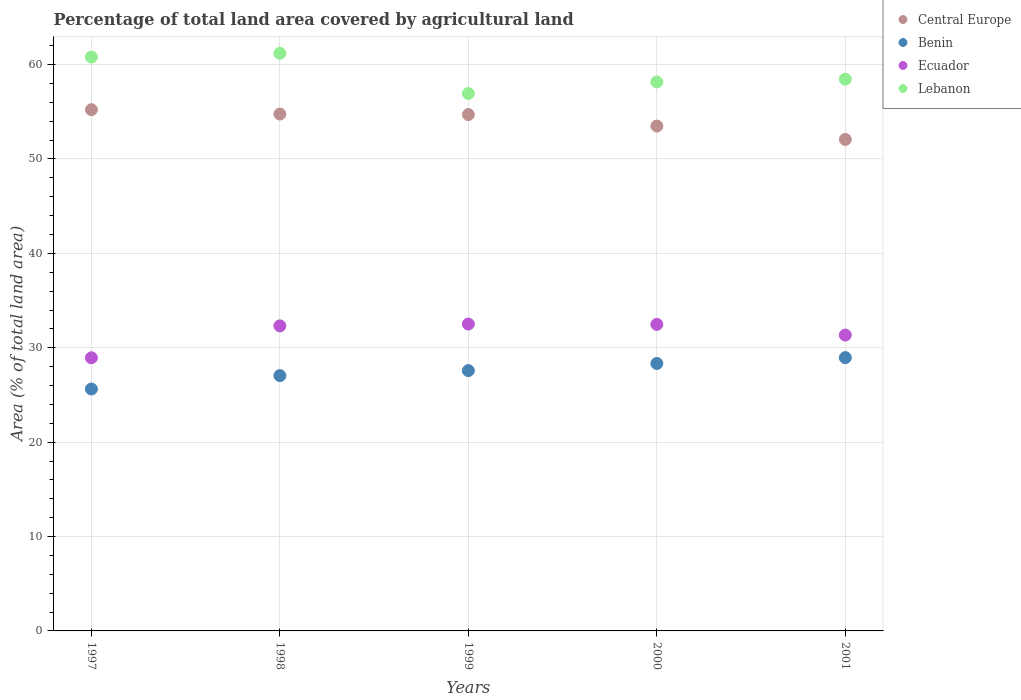Is the number of dotlines equal to the number of legend labels?
Keep it short and to the point. Yes. What is the percentage of agricultural land in Central Europe in 1998?
Keep it short and to the point. 54.76. Across all years, what is the maximum percentage of agricultural land in Lebanon?
Your answer should be compact. 61.19. Across all years, what is the minimum percentage of agricultural land in Benin?
Your answer should be compact. 25.63. In which year was the percentage of agricultural land in Lebanon maximum?
Your answer should be compact. 1998. In which year was the percentage of agricultural land in Lebanon minimum?
Your answer should be very brief. 1999. What is the total percentage of agricultural land in Lebanon in the graph?
Give a very brief answer. 295.55. What is the difference between the percentage of agricultural land in Central Europe in 1999 and that in 2001?
Provide a short and direct response. 2.63. What is the difference between the percentage of agricultural land in Benin in 1999 and the percentage of agricultural land in Ecuador in 2000?
Your answer should be very brief. -4.9. What is the average percentage of agricultural land in Lebanon per year?
Your response must be concise. 59.11. In the year 1997, what is the difference between the percentage of agricultural land in Central Europe and percentage of agricultural land in Lebanon?
Give a very brief answer. -5.57. What is the ratio of the percentage of agricultural land in Lebanon in 1999 to that in 2000?
Your response must be concise. 0.98. Is the percentage of agricultural land in Central Europe in 1999 less than that in 2000?
Provide a succinct answer. No. What is the difference between the highest and the second highest percentage of agricultural land in Ecuador?
Ensure brevity in your answer.  0.04. What is the difference between the highest and the lowest percentage of agricultural land in Central Europe?
Give a very brief answer. 3.15. In how many years, is the percentage of agricultural land in Lebanon greater than the average percentage of agricultural land in Lebanon taken over all years?
Your answer should be compact. 2. Does the percentage of agricultural land in Benin monotonically increase over the years?
Provide a succinct answer. Yes. Is the percentage of agricultural land in Lebanon strictly greater than the percentage of agricultural land in Benin over the years?
Make the answer very short. Yes. Is the percentage of agricultural land in Lebanon strictly less than the percentage of agricultural land in Ecuador over the years?
Your answer should be very brief. No. How many dotlines are there?
Ensure brevity in your answer.  4. How many years are there in the graph?
Offer a very short reply. 5. What is the difference between two consecutive major ticks on the Y-axis?
Your answer should be compact. 10. Are the values on the major ticks of Y-axis written in scientific E-notation?
Make the answer very short. No. Does the graph contain any zero values?
Offer a very short reply. No. Does the graph contain grids?
Your answer should be very brief. Yes. Where does the legend appear in the graph?
Ensure brevity in your answer.  Top right. How many legend labels are there?
Make the answer very short. 4. How are the legend labels stacked?
Make the answer very short. Vertical. What is the title of the graph?
Make the answer very short. Percentage of total land area covered by agricultural land. What is the label or title of the X-axis?
Give a very brief answer. Years. What is the label or title of the Y-axis?
Your response must be concise. Area (% of total land area). What is the Area (% of total land area) of Central Europe in 1997?
Keep it short and to the point. 55.23. What is the Area (% of total land area) in Benin in 1997?
Keep it short and to the point. 25.63. What is the Area (% of total land area) of Ecuador in 1997?
Ensure brevity in your answer.  28.94. What is the Area (% of total land area) in Lebanon in 1997?
Offer a terse response. 60.8. What is the Area (% of total land area) of Central Europe in 1998?
Provide a short and direct response. 54.76. What is the Area (% of total land area) of Benin in 1998?
Provide a succinct answer. 27.05. What is the Area (% of total land area) of Ecuador in 1998?
Your response must be concise. 32.32. What is the Area (% of total land area) of Lebanon in 1998?
Provide a short and direct response. 61.19. What is the Area (% of total land area) of Central Europe in 1999?
Keep it short and to the point. 54.71. What is the Area (% of total land area) in Benin in 1999?
Keep it short and to the point. 27.58. What is the Area (% of total land area) of Ecuador in 1999?
Make the answer very short. 32.51. What is the Area (% of total land area) in Lebanon in 1999?
Keep it short and to the point. 56.94. What is the Area (% of total land area) in Central Europe in 2000?
Provide a succinct answer. 53.49. What is the Area (% of total land area) of Benin in 2000?
Your answer should be very brief. 28.33. What is the Area (% of total land area) in Ecuador in 2000?
Provide a succinct answer. 32.48. What is the Area (% of total land area) of Lebanon in 2000?
Your response must be concise. 58.16. What is the Area (% of total land area) in Central Europe in 2001?
Provide a short and direct response. 52.07. What is the Area (% of total land area) in Benin in 2001?
Offer a very short reply. 28.96. What is the Area (% of total land area) of Ecuador in 2001?
Your answer should be very brief. 31.35. What is the Area (% of total land area) of Lebanon in 2001?
Your answer should be compact. 58.46. Across all years, what is the maximum Area (% of total land area) in Central Europe?
Provide a succinct answer. 55.23. Across all years, what is the maximum Area (% of total land area) in Benin?
Provide a succinct answer. 28.96. Across all years, what is the maximum Area (% of total land area) of Ecuador?
Ensure brevity in your answer.  32.51. Across all years, what is the maximum Area (% of total land area) in Lebanon?
Your answer should be very brief. 61.19. Across all years, what is the minimum Area (% of total land area) in Central Europe?
Offer a very short reply. 52.07. Across all years, what is the minimum Area (% of total land area) in Benin?
Make the answer very short. 25.63. Across all years, what is the minimum Area (% of total land area) of Ecuador?
Ensure brevity in your answer.  28.94. Across all years, what is the minimum Area (% of total land area) of Lebanon?
Ensure brevity in your answer.  56.94. What is the total Area (% of total land area) of Central Europe in the graph?
Give a very brief answer. 270.26. What is the total Area (% of total land area) in Benin in the graph?
Your response must be concise. 137.55. What is the total Area (% of total land area) of Ecuador in the graph?
Keep it short and to the point. 157.6. What is the total Area (% of total land area) in Lebanon in the graph?
Offer a very short reply. 295.55. What is the difference between the Area (% of total land area) of Central Europe in 1997 and that in 1998?
Provide a short and direct response. 0.47. What is the difference between the Area (% of total land area) in Benin in 1997 and that in 1998?
Provide a succinct answer. -1.42. What is the difference between the Area (% of total land area) of Ecuador in 1997 and that in 1998?
Your response must be concise. -3.38. What is the difference between the Area (% of total land area) of Lebanon in 1997 and that in 1998?
Offer a very short reply. -0.39. What is the difference between the Area (% of total land area) in Central Europe in 1997 and that in 1999?
Keep it short and to the point. 0.52. What is the difference between the Area (% of total land area) of Benin in 1997 and that in 1999?
Offer a very short reply. -1.95. What is the difference between the Area (% of total land area) of Ecuador in 1997 and that in 1999?
Offer a terse response. -3.57. What is the difference between the Area (% of total land area) in Lebanon in 1997 and that in 1999?
Give a very brief answer. 3.86. What is the difference between the Area (% of total land area) of Central Europe in 1997 and that in 2000?
Give a very brief answer. 1.74. What is the difference between the Area (% of total land area) in Benin in 1997 and that in 2000?
Ensure brevity in your answer.  -2.7. What is the difference between the Area (% of total land area) of Ecuador in 1997 and that in 2000?
Provide a succinct answer. -3.54. What is the difference between the Area (% of total land area) in Lebanon in 1997 and that in 2000?
Provide a short and direct response. 2.64. What is the difference between the Area (% of total land area) of Central Europe in 1997 and that in 2001?
Keep it short and to the point. 3.15. What is the difference between the Area (% of total land area) in Benin in 1997 and that in 2001?
Your response must be concise. -3.33. What is the difference between the Area (% of total land area) in Ecuador in 1997 and that in 2001?
Your answer should be compact. -2.4. What is the difference between the Area (% of total land area) in Lebanon in 1997 and that in 2001?
Provide a succinct answer. 2.35. What is the difference between the Area (% of total land area) in Central Europe in 1998 and that in 1999?
Offer a very short reply. 0.05. What is the difference between the Area (% of total land area) in Benin in 1998 and that in 1999?
Make the answer very short. -0.53. What is the difference between the Area (% of total land area) of Ecuador in 1998 and that in 1999?
Your answer should be very brief. -0.19. What is the difference between the Area (% of total land area) of Lebanon in 1998 and that in 1999?
Offer a very short reply. 4.25. What is the difference between the Area (% of total land area) in Central Europe in 1998 and that in 2000?
Provide a short and direct response. 1.27. What is the difference between the Area (% of total land area) in Benin in 1998 and that in 2000?
Offer a terse response. -1.29. What is the difference between the Area (% of total land area) in Ecuador in 1998 and that in 2000?
Your answer should be very brief. -0.16. What is the difference between the Area (% of total land area) of Lebanon in 1998 and that in 2000?
Provide a succinct answer. 3.03. What is the difference between the Area (% of total land area) of Central Europe in 1998 and that in 2001?
Make the answer very short. 2.69. What is the difference between the Area (% of total land area) of Benin in 1998 and that in 2001?
Provide a succinct answer. -1.91. What is the difference between the Area (% of total land area) of Ecuador in 1998 and that in 2001?
Your response must be concise. 0.97. What is the difference between the Area (% of total land area) in Lebanon in 1998 and that in 2001?
Your response must be concise. 2.74. What is the difference between the Area (% of total land area) of Central Europe in 1999 and that in 2000?
Provide a succinct answer. 1.22. What is the difference between the Area (% of total land area) in Benin in 1999 and that in 2000?
Give a very brief answer. -0.75. What is the difference between the Area (% of total land area) of Ecuador in 1999 and that in 2000?
Give a very brief answer. 0.04. What is the difference between the Area (% of total land area) in Lebanon in 1999 and that in 2000?
Give a very brief answer. -1.22. What is the difference between the Area (% of total land area) of Central Europe in 1999 and that in 2001?
Keep it short and to the point. 2.63. What is the difference between the Area (% of total land area) of Benin in 1999 and that in 2001?
Offer a terse response. -1.37. What is the difference between the Area (% of total land area) of Ecuador in 1999 and that in 2001?
Your answer should be very brief. 1.17. What is the difference between the Area (% of total land area) in Lebanon in 1999 and that in 2001?
Your response must be concise. -1.52. What is the difference between the Area (% of total land area) of Central Europe in 2000 and that in 2001?
Your answer should be compact. 1.42. What is the difference between the Area (% of total land area) in Benin in 2000 and that in 2001?
Provide a short and direct response. -0.62. What is the difference between the Area (% of total land area) in Ecuador in 2000 and that in 2001?
Keep it short and to the point. 1.13. What is the difference between the Area (% of total land area) of Lebanon in 2000 and that in 2001?
Provide a succinct answer. -0.29. What is the difference between the Area (% of total land area) in Central Europe in 1997 and the Area (% of total land area) in Benin in 1998?
Your response must be concise. 28.18. What is the difference between the Area (% of total land area) in Central Europe in 1997 and the Area (% of total land area) in Ecuador in 1998?
Ensure brevity in your answer.  22.91. What is the difference between the Area (% of total land area) in Central Europe in 1997 and the Area (% of total land area) in Lebanon in 1998?
Give a very brief answer. -5.97. What is the difference between the Area (% of total land area) of Benin in 1997 and the Area (% of total land area) of Ecuador in 1998?
Your answer should be compact. -6.69. What is the difference between the Area (% of total land area) of Benin in 1997 and the Area (% of total land area) of Lebanon in 1998?
Provide a succinct answer. -35.56. What is the difference between the Area (% of total land area) in Ecuador in 1997 and the Area (% of total land area) in Lebanon in 1998?
Ensure brevity in your answer.  -32.25. What is the difference between the Area (% of total land area) of Central Europe in 1997 and the Area (% of total land area) of Benin in 1999?
Offer a terse response. 27.65. What is the difference between the Area (% of total land area) of Central Europe in 1997 and the Area (% of total land area) of Ecuador in 1999?
Your answer should be compact. 22.71. What is the difference between the Area (% of total land area) of Central Europe in 1997 and the Area (% of total land area) of Lebanon in 1999?
Your answer should be compact. -1.71. What is the difference between the Area (% of total land area) in Benin in 1997 and the Area (% of total land area) in Ecuador in 1999?
Your answer should be very brief. -6.88. What is the difference between the Area (% of total land area) of Benin in 1997 and the Area (% of total land area) of Lebanon in 1999?
Offer a very short reply. -31.31. What is the difference between the Area (% of total land area) of Ecuador in 1997 and the Area (% of total land area) of Lebanon in 1999?
Your response must be concise. -28. What is the difference between the Area (% of total land area) of Central Europe in 1997 and the Area (% of total land area) of Benin in 2000?
Offer a terse response. 26.89. What is the difference between the Area (% of total land area) of Central Europe in 1997 and the Area (% of total land area) of Ecuador in 2000?
Your response must be concise. 22.75. What is the difference between the Area (% of total land area) of Central Europe in 1997 and the Area (% of total land area) of Lebanon in 2000?
Provide a succinct answer. -2.94. What is the difference between the Area (% of total land area) of Benin in 1997 and the Area (% of total land area) of Ecuador in 2000?
Make the answer very short. -6.85. What is the difference between the Area (% of total land area) of Benin in 1997 and the Area (% of total land area) of Lebanon in 2000?
Provide a short and direct response. -32.53. What is the difference between the Area (% of total land area) of Ecuador in 1997 and the Area (% of total land area) of Lebanon in 2000?
Make the answer very short. -29.22. What is the difference between the Area (% of total land area) of Central Europe in 1997 and the Area (% of total land area) of Benin in 2001?
Give a very brief answer. 26.27. What is the difference between the Area (% of total land area) in Central Europe in 1997 and the Area (% of total land area) in Ecuador in 2001?
Make the answer very short. 23.88. What is the difference between the Area (% of total land area) in Central Europe in 1997 and the Area (% of total land area) in Lebanon in 2001?
Make the answer very short. -3.23. What is the difference between the Area (% of total land area) in Benin in 1997 and the Area (% of total land area) in Ecuador in 2001?
Provide a succinct answer. -5.72. What is the difference between the Area (% of total land area) of Benin in 1997 and the Area (% of total land area) of Lebanon in 2001?
Offer a terse response. -32.83. What is the difference between the Area (% of total land area) in Ecuador in 1997 and the Area (% of total land area) in Lebanon in 2001?
Make the answer very short. -29.51. What is the difference between the Area (% of total land area) in Central Europe in 1998 and the Area (% of total land area) in Benin in 1999?
Offer a very short reply. 27.18. What is the difference between the Area (% of total land area) in Central Europe in 1998 and the Area (% of total land area) in Ecuador in 1999?
Your answer should be very brief. 22.25. What is the difference between the Area (% of total land area) of Central Europe in 1998 and the Area (% of total land area) of Lebanon in 1999?
Keep it short and to the point. -2.18. What is the difference between the Area (% of total land area) in Benin in 1998 and the Area (% of total land area) in Ecuador in 1999?
Keep it short and to the point. -5.46. What is the difference between the Area (% of total land area) of Benin in 1998 and the Area (% of total land area) of Lebanon in 1999?
Provide a succinct answer. -29.89. What is the difference between the Area (% of total land area) of Ecuador in 1998 and the Area (% of total land area) of Lebanon in 1999?
Offer a terse response. -24.62. What is the difference between the Area (% of total land area) in Central Europe in 1998 and the Area (% of total land area) in Benin in 2000?
Provide a short and direct response. 26.43. What is the difference between the Area (% of total land area) in Central Europe in 1998 and the Area (% of total land area) in Ecuador in 2000?
Keep it short and to the point. 22.28. What is the difference between the Area (% of total land area) of Central Europe in 1998 and the Area (% of total land area) of Lebanon in 2000?
Give a very brief answer. -3.4. What is the difference between the Area (% of total land area) in Benin in 1998 and the Area (% of total land area) in Ecuador in 2000?
Give a very brief answer. -5.43. What is the difference between the Area (% of total land area) of Benin in 1998 and the Area (% of total land area) of Lebanon in 2000?
Provide a succinct answer. -31.11. What is the difference between the Area (% of total land area) of Ecuador in 1998 and the Area (% of total land area) of Lebanon in 2000?
Keep it short and to the point. -25.84. What is the difference between the Area (% of total land area) in Central Europe in 1998 and the Area (% of total land area) in Benin in 2001?
Ensure brevity in your answer.  25.81. What is the difference between the Area (% of total land area) of Central Europe in 1998 and the Area (% of total land area) of Ecuador in 2001?
Offer a very short reply. 23.41. What is the difference between the Area (% of total land area) in Central Europe in 1998 and the Area (% of total land area) in Lebanon in 2001?
Your response must be concise. -3.7. What is the difference between the Area (% of total land area) of Benin in 1998 and the Area (% of total land area) of Ecuador in 2001?
Your answer should be very brief. -4.3. What is the difference between the Area (% of total land area) of Benin in 1998 and the Area (% of total land area) of Lebanon in 2001?
Provide a succinct answer. -31.41. What is the difference between the Area (% of total land area) of Ecuador in 1998 and the Area (% of total land area) of Lebanon in 2001?
Keep it short and to the point. -26.14. What is the difference between the Area (% of total land area) in Central Europe in 1999 and the Area (% of total land area) in Benin in 2000?
Keep it short and to the point. 26.37. What is the difference between the Area (% of total land area) of Central Europe in 1999 and the Area (% of total land area) of Ecuador in 2000?
Your answer should be very brief. 22.23. What is the difference between the Area (% of total land area) in Central Europe in 1999 and the Area (% of total land area) in Lebanon in 2000?
Offer a terse response. -3.45. What is the difference between the Area (% of total land area) in Benin in 1999 and the Area (% of total land area) in Ecuador in 2000?
Make the answer very short. -4.9. What is the difference between the Area (% of total land area) in Benin in 1999 and the Area (% of total land area) in Lebanon in 2000?
Ensure brevity in your answer.  -30.58. What is the difference between the Area (% of total land area) of Ecuador in 1999 and the Area (% of total land area) of Lebanon in 2000?
Your answer should be very brief. -25.65. What is the difference between the Area (% of total land area) of Central Europe in 1999 and the Area (% of total land area) of Benin in 2001?
Offer a very short reply. 25.75. What is the difference between the Area (% of total land area) of Central Europe in 1999 and the Area (% of total land area) of Ecuador in 2001?
Keep it short and to the point. 23.36. What is the difference between the Area (% of total land area) in Central Europe in 1999 and the Area (% of total land area) in Lebanon in 2001?
Offer a terse response. -3.75. What is the difference between the Area (% of total land area) of Benin in 1999 and the Area (% of total land area) of Ecuador in 2001?
Provide a succinct answer. -3.76. What is the difference between the Area (% of total land area) of Benin in 1999 and the Area (% of total land area) of Lebanon in 2001?
Your answer should be compact. -30.87. What is the difference between the Area (% of total land area) in Ecuador in 1999 and the Area (% of total land area) in Lebanon in 2001?
Your response must be concise. -25.94. What is the difference between the Area (% of total land area) in Central Europe in 2000 and the Area (% of total land area) in Benin in 2001?
Give a very brief answer. 24.54. What is the difference between the Area (% of total land area) in Central Europe in 2000 and the Area (% of total land area) in Ecuador in 2001?
Give a very brief answer. 22.15. What is the difference between the Area (% of total land area) in Central Europe in 2000 and the Area (% of total land area) in Lebanon in 2001?
Your answer should be very brief. -4.96. What is the difference between the Area (% of total land area) in Benin in 2000 and the Area (% of total land area) in Ecuador in 2001?
Provide a short and direct response. -3.01. What is the difference between the Area (% of total land area) of Benin in 2000 and the Area (% of total land area) of Lebanon in 2001?
Offer a very short reply. -30.12. What is the difference between the Area (% of total land area) in Ecuador in 2000 and the Area (% of total land area) in Lebanon in 2001?
Your response must be concise. -25.98. What is the average Area (% of total land area) of Central Europe per year?
Offer a very short reply. 54.05. What is the average Area (% of total land area) of Benin per year?
Offer a very short reply. 27.51. What is the average Area (% of total land area) in Ecuador per year?
Ensure brevity in your answer.  31.52. What is the average Area (% of total land area) of Lebanon per year?
Provide a succinct answer. 59.11. In the year 1997, what is the difference between the Area (% of total land area) in Central Europe and Area (% of total land area) in Benin?
Keep it short and to the point. 29.6. In the year 1997, what is the difference between the Area (% of total land area) of Central Europe and Area (% of total land area) of Ecuador?
Your response must be concise. 26.29. In the year 1997, what is the difference between the Area (% of total land area) of Central Europe and Area (% of total land area) of Lebanon?
Your response must be concise. -5.57. In the year 1997, what is the difference between the Area (% of total land area) of Benin and Area (% of total land area) of Ecuador?
Your answer should be very brief. -3.31. In the year 1997, what is the difference between the Area (% of total land area) of Benin and Area (% of total land area) of Lebanon?
Provide a short and direct response. -35.17. In the year 1997, what is the difference between the Area (% of total land area) in Ecuador and Area (% of total land area) in Lebanon?
Provide a short and direct response. -31.86. In the year 1998, what is the difference between the Area (% of total land area) of Central Europe and Area (% of total land area) of Benin?
Give a very brief answer. 27.71. In the year 1998, what is the difference between the Area (% of total land area) in Central Europe and Area (% of total land area) in Ecuador?
Offer a terse response. 22.44. In the year 1998, what is the difference between the Area (% of total land area) in Central Europe and Area (% of total land area) in Lebanon?
Keep it short and to the point. -6.43. In the year 1998, what is the difference between the Area (% of total land area) in Benin and Area (% of total land area) in Ecuador?
Make the answer very short. -5.27. In the year 1998, what is the difference between the Area (% of total land area) of Benin and Area (% of total land area) of Lebanon?
Make the answer very short. -34.14. In the year 1998, what is the difference between the Area (% of total land area) of Ecuador and Area (% of total land area) of Lebanon?
Your response must be concise. -28.87. In the year 1999, what is the difference between the Area (% of total land area) in Central Europe and Area (% of total land area) in Benin?
Make the answer very short. 27.13. In the year 1999, what is the difference between the Area (% of total land area) of Central Europe and Area (% of total land area) of Ecuador?
Give a very brief answer. 22.19. In the year 1999, what is the difference between the Area (% of total land area) in Central Europe and Area (% of total land area) in Lebanon?
Ensure brevity in your answer.  -2.23. In the year 1999, what is the difference between the Area (% of total land area) of Benin and Area (% of total land area) of Ecuador?
Ensure brevity in your answer.  -4.93. In the year 1999, what is the difference between the Area (% of total land area) of Benin and Area (% of total land area) of Lebanon?
Ensure brevity in your answer.  -29.36. In the year 1999, what is the difference between the Area (% of total land area) in Ecuador and Area (% of total land area) in Lebanon?
Give a very brief answer. -24.43. In the year 2000, what is the difference between the Area (% of total land area) in Central Europe and Area (% of total land area) in Benin?
Provide a succinct answer. 25.16. In the year 2000, what is the difference between the Area (% of total land area) of Central Europe and Area (% of total land area) of Ecuador?
Your answer should be very brief. 21.01. In the year 2000, what is the difference between the Area (% of total land area) of Central Europe and Area (% of total land area) of Lebanon?
Offer a very short reply. -4.67. In the year 2000, what is the difference between the Area (% of total land area) of Benin and Area (% of total land area) of Ecuador?
Keep it short and to the point. -4.14. In the year 2000, what is the difference between the Area (% of total land area) in Benin and Area (% of total land area) in Lebanon?
Offer a very short reply. -29.83. In the year 2000, what is the difference between the Area (% of total land area) in Ecuador and Area (% of total land area) in Lebanon?
Offer a very short reply. -25.69. In the year 2001, what is the difference between the Area (% of total land area) of Central Europe and Area (% of total land area) of Benin?
Offer a very short reply. 23.12. In the year 2001, what is the difference between the Area (% of total land area) in Central Europe and Area (% of total land area) in Ecuador?
Your response must be concise. 20.73. In the year 2001, what is the difference between the Area (% of total land area) in Central Europe and Area (% of total land area) in Lebanon?
Provide a succinct answer. -6.38. In the year 2001, what is the difference between the Area (% of total land area) in Benin and Area (% of total land area) in Ecuador?
Make the answer very short. -2.39. In the year 2001, what is the difference between the Area (% of total land area) of Benin and Area (% of total land area) of Lebanon?
Offer a very short reply. -29.5. In the year 2001, what is the difference between the Area (% of total land area) of Ecuador and Area (% of total land area) of Lebanon?
Keep it short and to the point. -27.11. What is the ratio of the Area (% of total land area) of Central Europe in 1997 to that in 1998?
Make the answer very short. 1.01. What is the ratio of the Area (% of total land area) of Benin in 1997 to that in 1998?
Make the answer very short. 0.95. What is the ratio of the Area (% of total land area) in Ecuador in 1997 to that in 1998?
Your response must be concise. 0.9. What is the ratio of the Area (% of total land area) in Central Europe in 1997 to that in 1999?
Provide a short and direct response. 1.01. What is the ratio of the Area (% of total land area) of Benin in 1997 to that in 1999?
Provide a succinct answer. 0.93. What is the ratio of the Area (% of total land area) of Ecuador in 1997 to that in 1999?
Provide a succinct answer. 0.89. What is the ratio of the Area (% of total land area) of Lebanon in 1997 to that in 1999?
Provide a succinct answer. 1.07. What is the ratio of the Area (% of total land area) of Central Europe in 1997 to that in 2000?
Offer a very short reply. 1.03. What is the ratio of the Area (% of total land area) in Benin in 1997 to that in 2000?
Offer a terse response. 0.9. What is the ratio of the Area (% of total land area) in Ecuador in 1997 to that in 2000?
Make the answer very short. 0.89. What is the ratio of the Area (% of total land area) in Lebanon in 1997 to that in 2000?
Your answer should be very brief. 1.05. What is the ratio of the Area (% of total land area) in Central Europe in 1997 to that in 2001?
Keep it short and to the point. 1.06. What is the ratio of the Area (% of total land area) in Benin in 1997 to that in 2001?
Make the answer very short. 0.89. What is the ratio of the Area (% of total land area) of Ecuador in 1997 to that in 2001?
Ensure brevity in your answer.  0.92. What is the ratio of the Area (% of total land area) of Lebanon in 1997 to that in 2001?
Your answer should be very brief. 1.04. What is the ratio of the Area (% of total land area) in Benin in 1998 to that in 1999?
Ensure brevity in your answer.  0.98. What is the ratio of the Area (% of total land area) of Ecuador in 1998 to that in 1999?
Keep it short and to the point. 0.99. What is the ratio of the Area (% of total land area) in Lebanon in 1998 to that in 1999?
Keep it short and to the point. 1.07. What is the ratio of the Area (% of total land area) in Central Europe in 1998 to that in 2000?
Ensure brevity in your answer.  1.02. What is the ratio of the Area (% of total land area) in Benin in 1998 to that in 2000?
Your response must be concise. 0.95. What is the ratio of the Area (% of total land area) in Lebanon in 1998 to that in 2000?
Your response must be concise. 1.05. What is the ratio of the Area (% of total land area) of Central Europe in 1998 to that in 2001?
Ensure brevity in your answer.  1.05. What is the ratio of the Area (% of total land area) of Benin in 1998 to that in 2001?
Offer a terse response. 0.93. What is the ratio of the Area (% of total land area) of Ecuador in 1998 to that in 2001?
Your response must be concise. 1.03. What is the ratio of the Area (% of total land area) of Lebanon in 1998 to that in 2001?
Make the answer very short. 1.05. What is the ratio of the Area (% of total land area) of Central Europe in 1999 to that in 2000?
Offer a terse response. 1.02. What is the ratio of the Area (% of total land area) of Benin in 1999 to that in 2000?
Ensure brevity in your answer.  0.97. What is the ratio of the Area (% of total land area) in Central Europe in 1999 to that in 2001?
Give a very brief answer. 1.05. What is the ratio of the Area (% of total land area) in Benin in 1999 to that in 2001?
Give a very brief answer. 0.95. What is the ratio of the Area (% of total land area) of Ecuador in 1999 to that in 2001?
Offer a very short reply. 1.04. What is the ratio of the Area (% of total land area) of Lebanon in 1999 to that in 2001?
Ensure brevity in your answer.  0.97. What is the ratio of the Area (% of total land area) of Central Europe in 2000 to that in 2001?
Your answer should be compact. 1.03. What is the ratio of the Area (% of total land area) in Benin in 2000 to that in 2001?
Offer a very short reply. 0.98. What is the ratio of the Area (% of total land area) in Ecuador in 2000 to that in 2001?
Provide a short and direct response. 1.04. What is the ratio of the Area (% of total land area) in Lebanon in 2000 to that in 2001?
Give a very brief answer. 0.99. What is the difference between the highest and the second highest Area (% of total land area) in Central Europe?
Provide a succinct answer. 0.47. What is the difference between the highest and the second highest Area (% of total land area) of Benin?
Your answer should be compact. 0.62. What is the difference between the highest and the second highest Area (% of total land area) in Ecuador?
Offer a terse response. 0.04. What is the difference between the highest and the second highest Area (% of total land area) of Lebanon?
Make the answer very short. 0.39. What is the difference between the highest and the lowest Area (% of total land area) of Central Europe?
Provide a succinct answer. 3.15. What is the difference between the highest and the lowest Area (% of total land area) of Benin?
Offer a very short reply. 3.33. What is the difference between the highest and the lowest Area (% of total land area) of Ecuador?
Offer a very short reply. 3.57. What is the difference between the highest and the lowest Area (% of total land area) of Lebanon?
Provide a succinct answer. 4.25. 